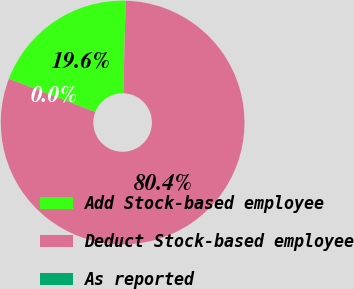Convert chart. <chart><loc_0><loc_0><loc_500><loc_500><pie_chart><fcel>Add Stock-based employee<fcel>Deduct Stock-based employee<fcel>As reported<nl><fcel>19.56%<fcel>80.44%<fcel>0.0%<nl></chart> 